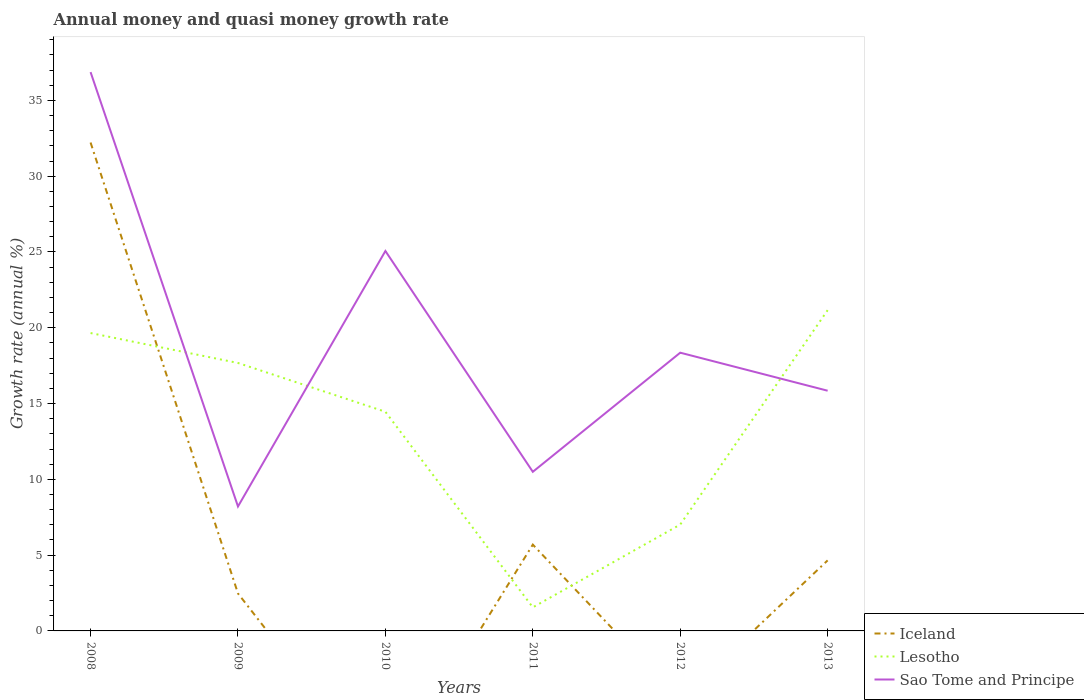Does the line corresponding to Sao Tome and Principe intersect with the line corresponding to Iceland?
Keep it short and to the point. No. Is the number of lines equal to the number of legend labels?
Your answer should be very brief. No. What is the total growth rate in Lesotho in the graph?
Your answer should be compact. 12.9. What is the difference between the highest and the second highest growth rate in Sao Tome and Principe?
Provide a short and direct response. 28.66. Is the growth rate in Sao Tome and Principe strictly greater than the growth rate in Iceland over the years?
Keep it short and to the point. No. How many years are there in the graph?
Make the answer very short. 6. Are the values on the major ticks of Y-axis written in scientific E-notation?
Keep it short and to the point. No. Does the graph contain grids?
Your answer should be very brief. No. How many legend labels are there?
Offer a very short reply. 3. How are the legend labels stacked?
Offer a terse response. Vertical. What is the title of the graph?
Provide a short and direct response. Annual money and quasi money growth rate. Does "Serbia" appear as one of the legend labels in the graph?
Give a very brief answer. No. What is the label or title of the Y-axis?
Your answer should be very brief. Growth rate (annual %). What is the Growth rate (annual %) in Iceland in 2008?
Offer a very short reply. 32.22. What is the Growth rate (annual %) in Lesotho in 2008?
Give a very brief answer. 19.65. What is the Growth rate (annual %) in Sao Tome and Principe in 2008?
Keep it short and to the point. 36.87. What is the Growth rate (annual %) in Iceland in 2009?
Give a very brief answer. 2.47. What is the Growth rate (annual %) of Lesotho in 2009?
Make the answer very short. 17.68. What is the Growth rate (annual %) of Sao Tome and Principe in 2009?
Your answer should be compact. 8.21. What is the Growth rate (annual %) of Iceland in 2010?
Make the answer very short. 0. What is the Growth rate (annual %) in Lesotho in 2010?
Ensure brevity in your answer.  14.46. What is the Growth rate (annual %) of Sao Tome and Principe in 2010?
Offer a terse response. 25.06. What is the Growth rate (annual %) in Iceland in 2011?
Your answer should be very brief. 5.69. What is the Growth rate (annual %) in Lesotho in 2011?
Offer a terse response. 1.55. What is the Growth rate (annual %) in Sao Tome and Principe in 2011?
Give a very brief answer. 10.5. What is the Growth rate (annual %) of Iceland in 2012?
Your response must be concise. 0. What is the Growth rate (annual %) in Lesotho in 2012?
Keep it short and to the point. 7.02. What is the Growth rate (annual %) of Sao Tome and Principe in 2012?
Your answer should be compact. 18.36. What is the Growth rate (annual %) of Iceland in 2013?
Make the answer very short. 4.65. What is the Growth rate (annual %) in Lesotho in 2013?
Your answer should be compact. 21.16. What is the Growth rate (annual %) of Sao Tome and Principe in 2013?
Provide a succinct answer. 15.85. Across all years, what is the maximum Growth rate (annual %) of Iceland?
Your answer should be very brief. 32.22. Across all years, what is the maximum Growth rate (annual %) of Lesotho?
Ensure brevity in your answer.  21.16. Across all years, what is the maximum Growth rate (annual %) in Sao Tome and Principe?
Your answer should be very brief. 36.87. Across all years, what is the minimum Growth rate (annual %) of Iceland?
Keep it short and to the point. 0. Across all years, what is the minimum Growth rate (annual %) of Lesotho?
Provide a succinct answer. 1.55. Across all years, what is the minimum Growth rate (annual %) of Sao Tome and Principe?
Your response must be concise. 8.21. What is the total Growth rate (annual %) in Iceland in the graph?
Make the answer very short. 45.04. What is the total Growth rate (annual %) in Lesotho in the graph?
Offer a very short reply. 81.52. What is the total Growth rate (annual %) in Sao Tome and Principe in the graph?
Provide a succinct answer. 114.84. What is the difference between the Growth rate (annual %) in Iceland in 2008 and that in 2009?
Keep it short and to the point. 29.75. What is the difference between the Growth rate (annual %) of Lesotho in 2008 and that in 2009?
Your response must be concise. 1.97. What is the difference between the Growth rate (annual %) in Sao Tome and Principe in 2008 and that in 2009?
Your answer should be very brief. 28.66. What is the difference between the Growth rate (annual %) in Lesotho in 2008 and that in 2010?
Make the answer very short. 5.19. What is the difference between the Growth rate (annual %) of Sao Tome and Principe in 2008 and that in 2010?
Offer a very short reply. 11.8. What is the difference between the Growth rate (annual %) in Iceland in 2008 and that in 2011?
Your answer should be very brief. 26.53. What is the difference between the Growth rate (annual %) in Lesotho in 2008 and that in 2011?
Make the answer very short. 18.1. What is the difference between the Growth rate (annual %) in Sao Tome and Principe in 2008 and that in 2011?
Your answer should be very brief. 26.37. What is the difference between the Growth rate (annual %) in Lesotho in 2008 and that in 2012?
Offer a terse response. 12.64. What is the difference between the Growth rate (annual %) of Sao Tome and Principe in 2008 and that in 2012?
Ensure brevity in your answer.  18.51. What is the difference between the Growth rate (annual %) of Iceland in 2008 and that in 2013?
Your answer should be compact. 27.57. What is the difference between the Growth rate (annual %) in Lesotho in 2008 and that in 2013?
Your answer should be compact. -1.51. What is the difference between the Growth rate (annual %) of Sao Tome and Principe in 2008 and that in 2013?
Keep it short and to the point. 21.02. What is the difference between the Growth rate (annual %) in Lesotho in 2009 and that in 2010?
Keep it short and to the point. 3.22. What is the difference between the Growth rate (annual %) in Sao Tome and Principe in 2009 and that in 2010?
Ensure brevity in your answer.  -16.86. What is the difference between the Growth rate (annual %) in Iceland in 2009 and that in 2011?
Offer a very short reply. -3.22. What is the difference between the Growth rate (annual %) in Lesotho in 2009 and that in 2011?
Offer a very short reply. 16.12. What is the difference between the Growth rate (annual %) of Sao Tome and Principe in 2009 and that in 2011?
Provide a short and direct response. -2.29. What is the difference between the Growth rate (annual %) in Lesotho in 2009 and that in 2012?
Your response must be concise. 10.66. What is the difference between the Growth rate (annual %) in Sao Tome and Principe in 2009 and that in 2012?
Your answer should be very brief. -10.15. What is the difference between the Growth rate (annual %) of Iceland in 2009 and that in 2013?
Offer a very short reply. -2.18. What is the difference between the Growth rate (annual %) in Lesotho in 2009 and that in 2013?
Your answer should be very brief. -3.48. What is the difference between the Growth rate (annual %) of Sao Tome and Principe in 2009 and that in 2013?
Your answer should be compact. -7.64. What is the difference between the Growth rate (annual %) of Lesotho in 2010 and that in 2011?
Give a very brief answer. 12.9. What is the difference between the Growth rate (annual %) in Sao Tome and Principe in 2010 and that in 2011?
Make the answer very short. 14.57. What is the difference between the Growth rate (annual %) of Lesotho in 2010 and that in 2012?
Your answer should be very brief. 7.44. What is the difference between the Growth rate (annual %) in Sao Tome and Principe in 2010 and that in 2012?
Keep it short and to the point. 6.71. What is the difference between the Growth rate (annual %) of Lesotho in 2010 and that in 2013?
Offer a terse response. -6.7. What is the difference between the Growth rate (annual %) of Sao Tome and Principe in 2010 and that in 2013?
Offer a terse response. 9.22. What is the difference between the Growth rate (annual %) in Lesotho in 2011 and that in 2012?
Provide a succinct answer. -5.46. What is the difference between the Growth rate (annual %) of Sao Tome and Principe in 2011 and that in 2012?
Make the answer very short. -7.86. What is the difference between the Growth rate (annual %) in Iceland in 2011 and that in 2013?
Provide a succinct answer. 1.04. What is the difference between the Growth rate (annual %) of Lesotho in 2011 and that in 2013?
Offer a terse response. -19.61. What is the difference between the Growth rate (annual %) in Sao Tome and Principe in 2011 and that in 2013?
Make the answer very short. -5.35. What is the difference between the Growth rate (annual %) of Lesotho in 2012 and that in 2013?
Provide a short and direct response. -14.14. What is the difference between the Growth rate (annual %) of Sao Tome and Principe in 2012 and that in 2013?
Provide a short and direct response. 2.51. What is the difference between the Growth rate (annual %) of Iceland in 2008 and the Growth rate (annual %) of Lesotho in 2009?
Provide a short and direct response. 14.54. What is the difference between the Growth rate (annual %) in Iceland in 2008 and the Growth rate (annual %) in Sao Tome and Principe in 2009?
Your answer should be very brief. 24.01. What is the difference between the Growth rate (annual %) of Lesotho in 2008 and the Growth rate (annual %) of Sao Tome and Principe in 2009?
Offer a very short reply. 11.44. What is the difference between the Growth rate (annual %) of Iceland in 2008 and the Growth rate (annual %) of Lesotho in 2010?
Provide a short and direct response. 17.76. What is the difference between the Growth rate (annual %) in Iceland in 2008 and the Growth rate (annual %) in Sao Tome and Principe in 2010?
Provide a short and direct response. 7.16. What is the difference between the Growth rate (annual %) in Lesotho in 2008 and the Growth rate (annual %) in Sao Tome and Principe in 2010?
Your answer should be compact. -5.41. What is the difference between the Growth rate (annual %) in Iceland in 2008 and the Growth rate (annual %) in Lesotho in 2011?
Provide a short and direct response. 30.67. What is the difference between the Growth rate (annual %) in Iceland in 2008 and the Growth rate (annual %) in Sao Tome and Principe in 2011?
Your answer should be compact. 21.72. What is the difference between the Growth rate (annual %) of Lesotho in 2008 and the Growth rate (annual %) of Sao Tome and Principe in 2011?
Provide a short and direct response. 9.16. What is the difference between the Growth rate (annual %) in Iceland in 2008 and the Growth rate (annual %) in Lesotho in 2012?
Provide a short and direct response. 25.2. What is the difference between the Growth rate (annual %) of Iceland in 2008 and the Growth rate (annual %) of Sao Tome and Principe in 2012?
Provide a succinct answer. 13.86. What is the difference between the Growth rate (annual %) of Lesotho in 2008 and the Growth rate (annual %) of Sao Tome and Principe in 2012?
Offer a terse response. 1.3. What is the difference between the Growth rate (annual %) of Iceland in 2008 and the Growth rate (annual %) of Lesotho in 2013?
Provide a succinct answer. 11.06. What is the difference between the Growth rate (annual %) of Iceland in 2008 and the Growth rate (annual %) of Sao Tome and Principe in 2013?
Offer a very short reply. 16.37. What is the difference between the Growth rate (annual %) in Lesotho in 2008 and the Growth rate (annual %) in Sao Tome and Principe in 2013?
Offer a very short reply. 3.81. What is the difference between the Growth rate (annual %) in Iceland in 2009 and the Growth rate (annual %) in Lesotho in 2010?
Ensure brevity in your answer.  -11.99. What is the difference between the Growth rate (annual %) of Iceland in 2009 and the Growth rate (annual %) of Sao Tome and Principe in 2010?
Offer a terse response. -22.59. What is the difference between the Growth rate (annual %) of Lesotho in 2009 and the Growth rate (annual %) of Sao Tome and Principe in 2010?
Give a very brief answer. -7.39. What is the difference between the Growth rate (annual %) of Iceland in 2009 and the Growth rate (annual %) of Lesotho in 2011?
Your answer should be very brief. 0.92. What is the difference between the Growth rate (annual %) in Iceland in 2009 and the Growth rate (annual %) in Sao Tome and Principe in 2011?
Offer a very short reply. -8.03. What is the difference between the Growth rate (annual %) of Lesotho in 2009 and the Growth rate (annual %) of Sao Tome and Principe in 2011?
Provide a short and direct response. 7.18. What is the difference between the Growth rate (annual %) of Iceland in 2009 and the Growth rate (annual %) of Lesotho in 2012?
Make the answer very short. -4.55. What is the difference between the Growth rate (annual %) in Iceland in 2009 and the Growth rate (annual %) in Sao Tome and Principe in 2012?
Provide a short and direct response. -15.89. What is the difference between the Growth rate (annual %) in Lesotho in 2009 and the Growth rate (annual %) in Sao Tome and Principe in 2012?
Give a very brief answer. -0.68. What is the difference between the Growth rate (annual %) in Iceland in 2009 and the Growth rate (annual %) in Lesotho in 2013?
Offer a terse response. -18.69. What is the difference between the Growth rate (annual %) of Iceland in 2009 and the Growth rate (annual %) of Sao Tome and Principe in 2013?
Offer a terse response. -13.38. What is the difference between the Growth rate (annual %) in Lesotho in 2009 and the Growth rate (annual %) in Sao Tome and Principe in 2013?
Your response must be concise. 1.83. What is the difference between the Growth rate (annual %) of Lesotho in 2010 and the Growth rate (annual %) of Sao Tome and Principe in 2011?
Give a very brief answer. 3.96. What is the difference between the Growth rate (annual %) in Lesotho in 2010 and the Growth rate (annual %) in Sao Tome and Principe in 2012?
Ensure brevity in your answer.  -3.9. What is the difference between the Growth rate (annual %) in Lesotho in 2010 and the Growth rate (annual %) in Sao Tome and Principe in 2013?
Give a very brief answer. -1.39. What is the difference between the Growth rate (annual %) of Iceland in 2011 and the Growth rate (annual %) of Lesotho in 2012?
Your response must be concise. -1.32. What is the difference between the Growth rate (annual %) of Iceland in 2011 and the Growth rate (annual %) of Sao Tome and Principe in 2012?
Offer a very short reply. -12.66. What is the difference between the Growth rate (annual %) in Lesotho in 2011 and the Growth rate (annual %) in Sao Tome and Principe in 2012?
Make the answer very short. -16.8. What is the difference between the Growth rate (annual %) of Iceland in 2011 and the Growth rate (annual %) of Lesotho in 2013?
Your response must be concise. -15.47. What is the difference between the Growth rate (annual %) in Iceland in 2011 and the Growth rate (annual %) in Sao Tome and Principe in 2013?
Provide a succinct answer. -10.15. What is the difference between the Growth rate (annual %) of Lesotho in 2011 and the Growth rate (annual %) of Sao Tome and Principe in 2013?
Your response must be concise. -14.29. What is the difference between the Growth rate (annual %) in Lesotho in 2012 and the Growth rate (annual %) in Sao Tome and Principe in 2013?
Provide a succinct answer. -8.83. What is the average Growth rate (annual %) of Iceland per year?
Ensure brevity in your answer.  7.51. What is the average Growth rate (annual %) of Lesotho per year?
Ensure brevity in your answer.  13.59. What is the average Growth rate (annual %) of Sao Tome and Principe per year?
Provide a short and direct response. 19.14. In the year 2008, what is the difference between the Growth rate (annual %) in Iceland and Growth rate (annual %) in Lesotho?
Give a very brief answer. 12.57. In the year 2008, what is the difference between the Growth rate (annual %) in Iceland and Growth rate (annual %) in Sao Tome and Principe?
Your answer should be compact. -4.65. In the year 2008, what is the difference between the Growth rate (annual %) of Lesotho and Growth rate (annual %) of Sao Tome and Principe?
Offer a very short reply. -17.21. In the year 2009, what is the difference between the Growth rate (annual %) of Iceland and Growth rate (annual %) of Lesotho?
Keep it short and to the point. -15.21. In the year 2009, what is the difference between the Growth rate (annual %) in Iceland and Growth rate (annual %) in Sao Tome and Principe?
Your answer should be very brief. -5.74. In the year 2009, what is the difference between the Growth rate (annual %) in Lesotho and Growth rate (annual %) in Sao Tome and Principe?
Your answer should be very brief. 9.47. In the year 2010, what is the difference between the Growth rate (annual %) of Lesotho and Growth rate (annual %) of Sao Tome and Principe?
Keep it short and to the point. -10.61. In the year 2011, what is the difference between the Growth rate (annual %) of Iceland and Growth rate (annual %) of Lesotho?
Offer a very short reply. 4.14. In the year 2011, what is the difference between the Growth rate (annual %) in Iceland and Growth rate (annual %) in Sao Tome and Principe?
Make the answer very short. -4.8. In the year 2011, what is the difference between the Growth rate (annual %) of Lesotho and Growth rate (annual %) of Sao Tome and Principe?
Offer a very short reply. -8.94. In the year 2012, what is the difference between the Growth rate (annual %) in Lesotho and Growth rate (annual %) in Sao Tome and Principe?
Offer a very short reply. -11.34. In the year 2013, what is the difference between the Growth rate (annual %) of Iceland and Growth rate (annual %) of Lesotho?
Provide a short and direct response. -16.51. In the year 2013, what is the difference between the Growth rate (annual %) of Iceland and Growth rate (annual %) of Sao Tome and Principe?
Your response must be concise. -11.19. In the year 2013, what is the difference between the Growth rate (annual %) in Lesotho and Growth rate (annual %) in Sao Tome and Principe?
Your answer should be compact. 5.31. What is the ratio of the Growth rate (annual %) in Iceland in 2008 to that in 2009?
Provide a short and direct response. 13.04. What is the ratio of the Growth rate (annual %) in Lesotho in 2008 to that in 2009?
Your response must be concise. 1.11. What is the ratio of the Growth rate (annual %) in Sao Tome and Principe in 2008 to that in 2009?
Your answer should be very brief. 4.49. What is the ratio of the Growth rate (annual %) of Lesotho in 2008 to that in 2010?
Keep it short and to the point. 1.36. What is the ratio of the Growth rate (annual %) of Sao Tome and Principe in 2008 to that in 2010?
Make the answer very short. 1.47. What is the ratio of the Growth rate (annual %) of Iceland in 2008 to that in 2011?
Give a very brief answer. 5.66. What is the ratio of the Growth rate (annual %) of Lesotho in 2008 to that in 2011?
Provide a short and direct response. 12.64. What is the ratio of the Growth rate (annual %) of Sao Tome and Principe in 2008 to that in 2011?
Offer a terse response. 3.51. What is the ratio of the Growth rate (annual %) in Lesotho in 2008 to that in 2012?
Provide a short and direct response. 2.8. What is the ratio of the Growth rate (annual %) in Sao Tome and Principe in 2008 to that in 2012?
Provide a short and direct response. 2.01. What is the ratio of the Growth rate (annual %) of Iceland in 2008 to that in 2013?
Ensure brevity in your answer.  6.92. What is the ratio of the Growth rate (annual %) in Lesotho in 2008 to that in 2013?
Your response must be concise. 0.93. What is the ratio of the Growth rate (annual %) in Sao Tome and Principe in 2008 to that in 2013?
Your response must be concise. 2.33. What is the ratio of the Growth rate (annual %) of Lesotho in 2009 to that in 2010?
Your answer should be compact. 1.22. What is the ratio of the Growth rate (annual %) in Sao Tome and Principe in 2009 to that in 2010?
Your answer should be very brief. 0.33. What is the ratio of the Growth rate (annual %) in Iceland in 2009 to that in 2011?
Your answer should be compact. 0.43. What is the ratio of the Growth rate (annual %) in Lesotho in 2009 to that in 2011?
Your answer should be very brief. 11.37. What is the ratio of the Growth rate (annual %) of Sao Tome and Principe in 2009 to that in 2011?
Provide a succinct answer. 0.78. What is the ratio of the Growth rate (annual %) of Lesotho in 2009 to that in 2012?
Your answer should be compact. 2.52. What is the ratio of the Growth rate (annual %) of Sao Tome and Principe in 2009 to that in 2012?
Your response must be concise. 0.45. What is the ratio of the Growth rate (annual %) in Iceland in 2009 to that in 2013?
Keep it short and to the point. 0.53. What is the ratio of the Growth rate (annual %) of Lesotho in 2009 to that in 2013?
Your answer should be compact. 0.84. What is the ratio of the Growth rate (annual %) of Sao Tome and Principe in 2009 to that in 2013?
Your answer should be very brief. 0.52. What is the ratio of the Growth rate (annual %) in Lesotho in 2010 to that in 2011?
Offer a very short reply. 9.3. What is the ratio of the Growth rate (annual %) in Sao Tome and Principe in 2010 to that in 2011?
Make the answer very short. 2.39. What is the ratio of the Growth rate (annual %) of Lesotho in 2010 to that in 2012?
Make the answer very short. 2.06. What is the ratio of the Growth rate (annual %) in Sao Tome and Principe in 2010 to that in 2012?
Offer a terse response. 1.37. What is the ratio of the Growth rate (annual %) of Lesotho in 2010 to that in 2013?
Keep it short and to the point. 0.68. What is the ratio of the Growth rate (annual %) in Sao Tome and Principe in 2010 to that in 2013?
Make the answer very short. 1.58. What is the ratio of the Growth rate (annual %) in Lesotho in 2011 to that in 2012?
Ensure brevity in your answer.  0.22. What is the ratio of the Growth rate (annual %) of Sao Tome and Principe in 2011 to that in 2012?
Your answer should be very brief. 0.57. What is the ratio of the Growth rate (annual %) in Iceland in 2011 to that in 2013?
Provide a succinct answer. 1.22. What is the ratio of the Growth rate (annual %) in Lesotho in 2011 to that in 2013?
Offer a terse response. 0.07. What is the ratio of the Growth rate (annual %) in Sao Tome and Principe in 2011 to that in 2013?
Your answer should be compact. 0.66. What is the ratio of the Growth rate (annual %) of Lesotho in 2012 to that in 2013?
Your response must be concise. 0.33. What is the ratio of the Growth rate (annual %) of Sao Tome and Principe in 2012 to that in 2013?
Provide a succinct answer. 1.16. What is the difference between the highest and the second highest Growth rate (annual %) in Iceland?
Your response must be concise. 26.53. What is the difference between the highest and the second highest Growth rate (annual %) in Lesotho?
Your response must be concise. 1.51. What is the difference between the highest and the second highest Growth rate (annual %) of Sao Tome and Principe?
Provide a short and direct response. 11.8. What is the difference between the highest and the lowest Growth rate (annual %) in Iceland?
Provide a succinct answer. 32.22. What is the difference between the highest and the lowest Growth rate (annual %) in Lesotho?
Your response must be concise. 19.61. What is the difference between the highest and the lowest Growth rate (annual %) of Sao Tome and Principe?
Provide a short and direct response. 28.66. 